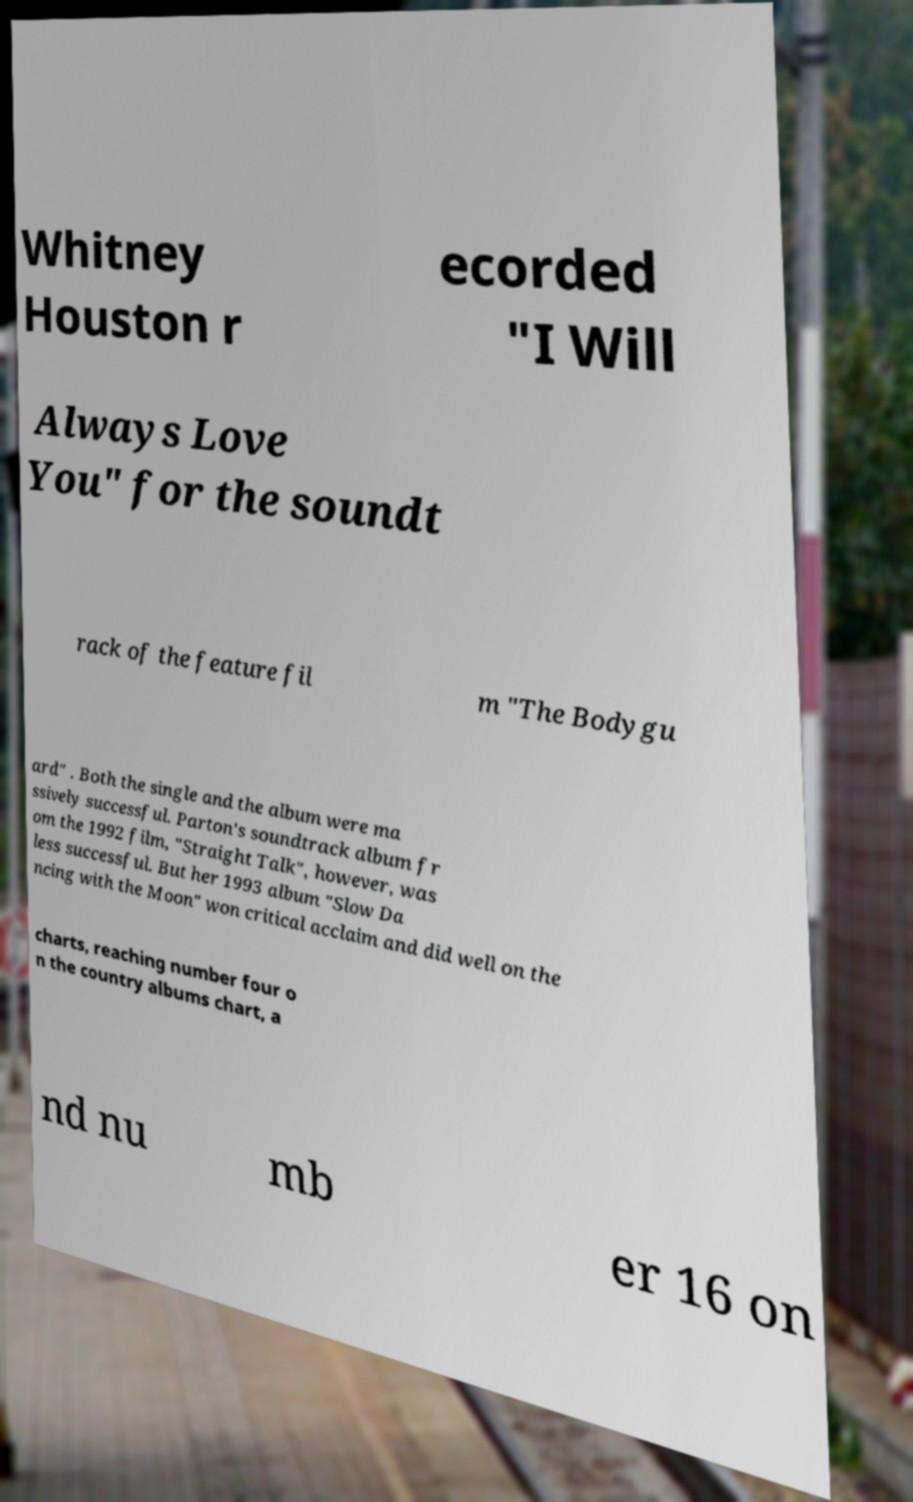Can you accurately transcribe the text from the provided image for me? Whitney Houston r ecorded "I Will Always Love You" for the soundt rack of the feature fil m "The Bodygu ard" . Both the single and the album were ma ssively successful. Parton's soundtrack album fr om the 1992 film, "Straight Talk", however, was less successful. But her 1993 album "Slow Da ncing with the Moon" won critical acclaim and did well on the charts, reaching number four o n the country albums chart, a nd nu mb er 16 on 